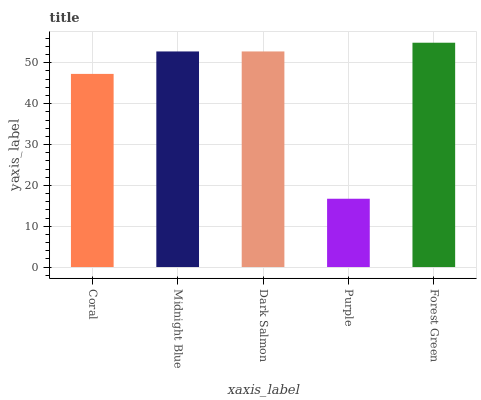Is Purple the minimum?
Answer yes or no. Yes. Is Forest Green the maximum?
Answer yes or no. Yes. Is Midnight Blue the minimum?
Answer yes or no. No. Is Midnight Blue the maximum?
Answer yes or no. No. Is Midnight Blue greater than Coral?
Answer yes or no. Yes. Is Coral less than Midnight Blue?
Answer yes or no. Yes. Is Coral greater than Midnight Blue?
Answer yes or no. No. Is Midnight Blue less than Coral?
Answer yes or no. No. Is Midnight Blue the high median?
Answer yes or no. Yes. Is Midnight Blue the low median?
Answer yes or no. Yes. Is Coral the high median?
Answer yes or no. No. Is Dark Salmon the low median?
Answer yes or no. No. 